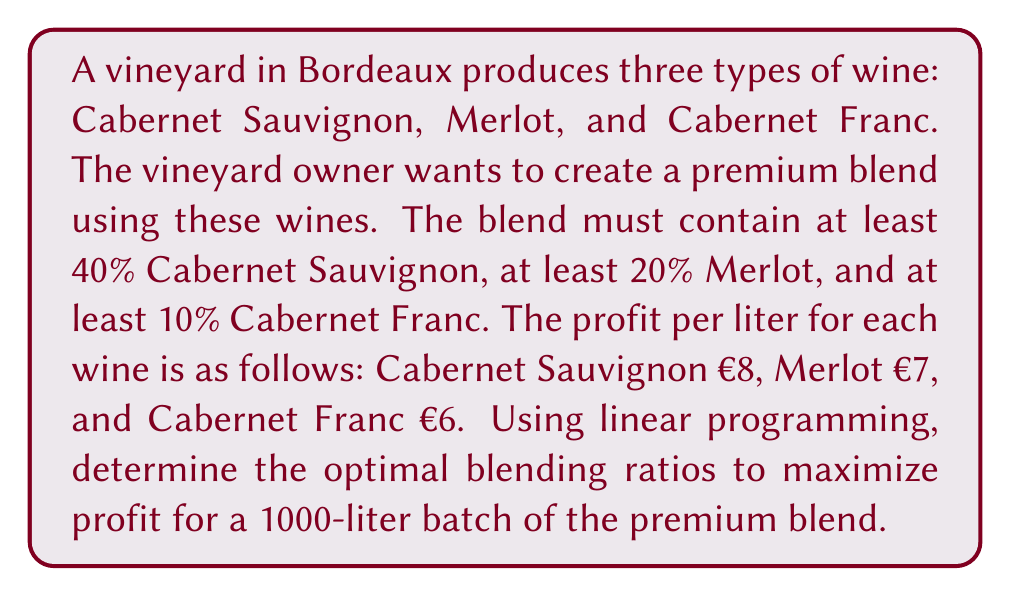Solve this math problem. To solve this problem using linear programming, we need to follow these steps:

1. Define the variables:
   Let $x_1$, $x_2$, and $x_3$ represent the proportions of Cabernet Sauvignon, Merlot, and Cabernet Franc in the blend, respectively.

2. Set up the objective function:
   Maximize profit: $Z = 8x_1 + 7x_2 + 6x_3$

3. Define the constraints:
   a) Minimum proportions:
      $x_1 \geq 0.4$ (Cabernet Sauvignon)
      $x_2 \geq 0.2$ (Merlot)
      $x_3 \geq 0.1$ (Cabernet Franc)
   b) Total proportion must equal 1:
      $x_1 + x_2 + x_3 = 1$

4. Solve the linear programming problem:
   We can solve this using the simplex method or graphically. In this case, we can solve it by considering the constraints:

   - We must use at least 40% Cabernet Sauvignon, 20% Merlot, and 10% Cabernet Franc.
   - The remaining 30% should be allocated to maximize profit.
   - Cabernet Sauvignon has the highest profit per liter, so we should allocate the remaining 30% to it.

5. Calculate the optimal solution:
   $x_1 = 0.7$ (70% Cabernet Sauvignon)
   $x_2 = 0.2$ (20% Merlot)
   $x_3 = 0.1$ (10% Cabernet Franc)

6. Calculate the maximum profit for a 1000-liter batch:
   $\text{Profit} = 1000 \times (8 \times 0.7 + 7 \times 0.2 + 6 \times 0.1)$
   $= 1000 \times (5.6 + 1.4 + 0.6)$
   $= 1000 \times 7.6$
   $= €7600$
Answer: The optimal blending ratios are 70% Cabernet Sauvignon, 20% Merlot, and 10% Cabernet Franc. The maximum profit for a 1000-liter batch of the premium blend is €7600. 